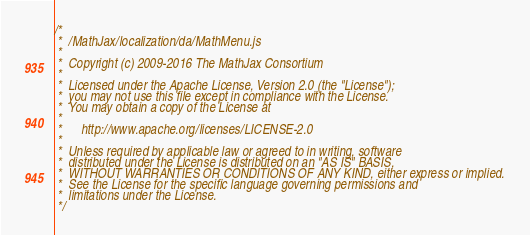Convert code to text. <code><loc_0><loc_0><loc_500><loc_500><_JavaScript_>/*
 *  /MathJax/localization/da/MathMenu.js
 *
 *  Copyright (c) 2009-2016 The MathJax Consortium
 *
 *  Licensed under the Apache License, Version 2.0 (the "License");
 *  you may not use this file except in compliance with the License.
 *  You may obtain a copy of the License at
 *
 *      http://www.apache.org/licenses/LICENSE-2.0
 *
 *  Unless required by applicable law or agreed to in writing, software
 *  distributed under the License is distributed on an "AS IS" BASIS,
 *  WITHOUT WARRANTIES OR CONDITIONS OF ANY KIND, either express or implied.
 *  See the License for the specific language governing permissions and
 *  limitations under the License.
 */
</code> 